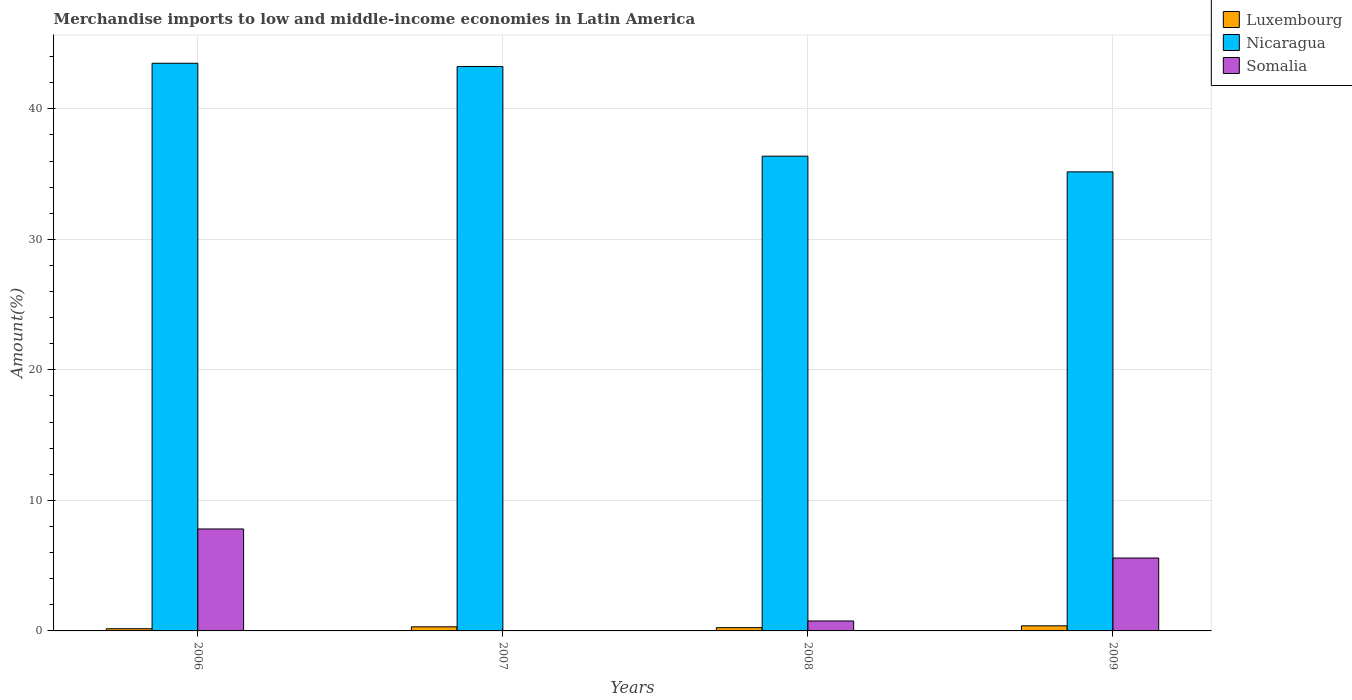How many different coloured bars are there?
Your answer should be compact. 3. How many groups of bars are there?
Provide a succinct answer. 4. Are the number of bars per tick equal to the number of legend labels?
Your answer should be very brief. Yes. Are the number of bars on each tick of the X-axis equal?
Ensure brevity in your answer.  Yes. How many bars are there on the 2nd tick from the right?
Provide a succinct answer. 3. What is the label of the 2nd group of bars from the left?
Give a very brief answer. 2007. In how many cases, is the number of bars for a given year not equal to the number of legend labels?
Keep it short and to the point. 0. What is the percentage of amount earned from merchandise imports in Somalia in 2009?
Provide a succinct answer. 5.59. Across all years, what is the maximum percentage of amount earned from merchandise imports in Luxembourg?
Your answer should be very brief. 0.39. Across all years, what is the minimum percentage of amount earned from merchandise imports in Somalia?
Offer a terse response. 0.02. In which year was the percentage of amount earned from merchandise imports in Somalia maximum?
Your response must be concise. 2006. In which year was the percentage of amount earned from merchandise imports in Somalia minimum?
Provide a short and direct response. 2007. What is the total percentage of amount earned from merchandise imports in Nicaragua in the graph?
Offer a very short reply. 158.27. What is the difference between the percentage of amount earned from merchandise imports in Somalia in 2007 and that in 2008?
Your answer should be compact. -0.74. What is the difference between the percentage of amount earned from merchandise imports in Luxembourg in 2008 and the percentage of amount earned from merchandise imports in Nicaragua in 2009?
Give a very brief answer. -34.92. What is the average percentage of amount earned from merchandise imports in Nicaragua per year?
Ensure brevity in your answer.  39.57. In the year 2006, what is the difference between the percentage of amount earned from merchandise imports in Somalia and percentage of amount earned from merchandise imports in Nicaragua?
Your response must be concise. -35.68. In how many years, is the percentage of amount earned from merchandise imports in Nicaragua greater than 10 %?
Keep it short and to the point. 4. What is the ratio of the percentage of amount earned from merchandise imports in Luxembourg in 2006 to that in 2009?
Your response must be concise. 0.43. Is the difference between the percentage of amount earned from merchandise imports in Somalia in 2006 and 2009 greater than the difference between the percentage of amount earned from merchandise imports in Nicaragua in 2006 and 2009?
Your answer should be compact. No. What is the difference between the highest and the second highest percentage of amount earned from merchandise imports in Somalia?
Your answer should be very brief. 2.23. What is the difference between the highest and the lowest percentage of amount earned from merchandise imports in Nicaragua?
Offer a terse response. 8.32. In how many years, is the percentage of amount earned from merchandise imports in Luxembourg greater than the average percentage of amount earned from merchandise imports in Luxembourg taken over all years?
Offer a very short reply. 2. What does the 3rd bar from the left in 2008 represents?
Your response must be concise. Somalia. What does the 3rd bar from the right in 2009 represents?
Keep it short and to the point. Luxembourg. Are the values on the major ticks of Y-axis written in scientific E-notation?
Offer a terse response. No. Does the graph contain grids?
Make the answer very short. Yes. What is the title of the graph?
Your answer should be very brief. Merchandise imports to low and middle-income economies in Latin America. Does "Liberia" appear as one of the legend labels in the graph?
Provide a succinct answer. No. What is the label or title of the Y-axis?
Your answer should be very brief. Amount(%). What is the Amount(%) in Luxembourg in 2006?
Give a very brief answer. 0.17. What is the Amount(%) of Nicaragua in 2006?
Your answer should be compact. 43.49. What is the Amount(%) in Somalia in 2006?
Make the answer very short. 7.81. What is the Amount(%) of Luxembourg in 2007?
Your response must be concise. 0.31. What is the Amount(%) in Nicaragua in 2007?
Provide a succinct answer. 43.24. What is the Amount(%) in Somalia in 2007?
Keep it short and to the point. 0.02. What is the Amount(%) in Luxembourg in 2008?
Your answer should be very brief. 0.25. What is the Amount(%) in Nicaragua in 2008?
Offer a very short reply. 36.37. What is the Amount(%) in Somalia in 2008?
Your answer should be compact. 0.76. What is the Amount(%) in Luxembourg in 2009?
Give a very brief answer. 0.39. What is the Amount(%) of Nicaragua in 2009?
Ensure brevity in your answer.  35.17. What is the Amount(%) in Somalia in 2009?
Your answer should be very brief. 5.59. Across all years, what is the maximum Amount(%) in Luxembourg?
Ensure brevity in your answer.  0.39. Across all years, what is the maximum Amount(%) of Nicaragua?
Your answer should be compact. 43.49. Across all years, what is the maximum Amount(%) of Somalia?
Keep it short and to the point. 7.81. Across all years, what is the minimum Amount(%) in Luxembourg?
Make the answer very short. 0.17. Across all years, what is the minimum Amount(%) of Nicaragua?
Keep it short and to the point. 35.17. Across all years, what is the minimum Amount(%) in Somalia?
Provide a succinct answer. 0.02. What is the total Amount(%) in Luxembourg in the graph?
Ensure brevity in your answer.  1.12. What is the total Amount(%) in Nicaragua in the graph?
Offer a very short reply. 158.27. What is the total Amount(%) of Somalia in the graph?
Keep it short and to the point. 14.18. What is the difference between the Amount(%) in Luxembourg in 2006 and that in 2007?
Ensure brevity in your answer.  -0.14. What is the difference between the Amount(%) of Nicaragua in 2006 and that in 2007?
Provide a succinct answer. 0.25. What is the difference between the Amount(%) of Somalia in 2006 and that in 2007?
Offer a very short reply. 7.79. What is the difference between the Amount(%) in Luxembourg in 2006 and that in 2008?
Ensure brevity in your answer.  -0.08. What is the difference between the Amount(%) in Nicaragua in 2006 and that in 2008?
Offer a very short reply. 7.12. What is the difference between the Amount(%) in Somalia in 2006 and that in 2008?
Your answer should be very brief. 7.05. What is the difference between the Amount(%) in Luxembourg in 2006 and that in 2009?
Your response must be concise. -0.22. What is the difference between the Amount(%) of Nicaragua in 2006 and that in 2009?
Offer a very short reply. 8.32. What is the difference between the Amount(%) of Somalia in 2006 and that in 2009?
Make the answer very short. 2.23. What is the difference between the Amount(%) in Luxembourg in 2007 and that in 2008?
Offer a terse response. 0.06. What is the difference between the Amount(%) of Nicaragua in 2007 and that in 2008?
Your answer should be compact. 6.87. What is the difference between the Amount(%) in Somalia in 2007 and that in 2008?
Your response must be concise. -0.74. What is the difference between the Amount(%) in Luxembourg in 2007 and that in 2009?
Your answer should be very brief. -0.08. What is the difference between the Amount(%) in Nicaragua in 2007 and that in 2009?
Ensure brevity in your answer.  8.07. What is the difference between the Amount(%) in Somalia in 2007 and that in 2009?
Give a very brief answer. -5.56. What is the difference between the Amount(%) in Luxembourg in 2008 and that in 2009?
Ensure brevity in your answer.  -0.14. What is the difference between the Amount(%) in Nicaragua in 2008 and that in 2009?
Your response must be concise. 1.2. What is the difference between the Amount(%) of Somalia in 2008 and that in 2009?
Your answer should be very brief. -4.82. What is the difference between the Amount(%) in Luxembourg in 2006 and the Amount(%) in Nicaragua in 2007?
Give a very brief answer. -43.07. What is the difference between the Amount(%) of Luxembourg in 2006 and the Amount(%) of Somalia in 2007?
Offer a terse response. 0.15. What is the difference between the Amount(%) in Nicaragua in 2006 and the Amount(%) in Somalia in 2007?
Ensure brevity in your answer.  43.47. What is the difference between the Amount(%) of Luxembourg in 2006 and the Amount(%) of Nicaragua in 2008?
Offer a very short reply. -36.2. What is the difference between the Amount(%) in Luxembourg in 2006 and the Amount(%) in Somalia in 2008?
Keep it short and to the point. -0.59. What is the difference between the Amount(%) of Nicaragua in 2006 and the Amount(%) of Somalia in 2008?
Your answer should be very brief. 42.73. What is the difference between the Amount(%) in Luxembourg in 2006 and the Amount(%) in Nicaragua in 2009?
Your answer should be very brief. -35. What is the difference between the Amount(%) of Luxembourg in 2006 and the Amount(%) of Somalia in 2009?
Offer a terse response. -5.42. What is the difference between the Amount(%) of Nicaragua in 2006 and the Amount(%) of Somalia in 2009?
Your answer should be very brief. 37.9. What is the difference between the Amount(%) of Luxembourg in 2007 and the Amount(%) of Nicaragua in 2008?
Your answer should be compact. -36.06. What is the difference between the Amount(%) in Luxembourg in 2007 and the Amount(%) in Somalia in 2008?
Offer a very short reply. -0.45. What is the difference between the Amount(%) in Nicaragua in 2007 and the Amount(%) in Somalia in 2008?
Offer a very short reply. 42.48. What is the difference between the Amount(%) of Luxembourg in 2007 and the Amount(%) of Nicaragua in 2009?
Give a very brief answer. -34.86. What is the difference between the Amount(%) in Luxembourg in 2007 and the Amount(%) in Somalia in 2009?
Your response must be concise. -5.27. What is the difference between the Amount(%) of Nicaragua in 2007 and the Amount(%) of Somalia in 2009?
Make the answer very short. 37.65. What is the difference between the Amount(%) of Luxembourg in 2008 and the Amount(%) of Nicaragua in 2009?
Offer a very short reply. -34.92. What is the difference between the Amount(%) in Luxembourg in 2008 and the Amount(%) in Somalia in 2009?
Offer a terse response. -5.34. What is the difference between the Amount(%) of Nicaragua in 2008 and the Amount(%) of Somalia in 2009?
Provide a short and direct response. 30.79. What is the average Amount(%) of Luxembourg per year?
Ensure brevity in your answer.  0.28. What is the average Amount(%) of Nicaragua per year?
Make the answer very short. 39.57. What is the average Amount(%) in Somalia per year?
Your response must be concise. 3.54. In the year 2006, what is the difference between the Amount(%) in Luxembourg and Amount(%) in Nicaragua?
Ensure brevity in your answer.  -43.32. In the year 2006, what is the difference between the Amount(%) of Luxembourg and Amount(%) of Somalia?
Your response must be concise. -7.64. In the year 2006, what is the difference between the Amount(%) of Nicaragua and Amount(%) of Somalia?
Your response must be concise. 35.68. In the year 2007, what is the difference between the Amount(%) of Luxembourg and Amount(%) of Nicaragua?
Keep it short and to the point. -42.93. In the year 2007, what is the difference between the Amount(%) in Luxembourg and Amount(%) in Somalia?
Ensure brevity in your answer.  0.29. In the year 2007, what is the difference between the Amount(%) of Nicaragua and Amount(%) of Somalia?
Offer a terse response. 43.22. In the year 2008, what is the difference between the Amount(%) of Luxembourg and Amount(%) of Nicaragua?
Make the answer very short. -36.12. In the year 2008, what is the difference between the Amount(%) of Luxembourg and Amount(%) of Somalia?
Your response must be concise. -0.51. In the year 2008, what is the difference between the Amount(%) in Nicaragua and Amount(%) in Somalia?
Offer a very short reply. 35.61. In the year 2009, what is the difference between the Amount(%) of Luxembourg and Amount(%) of Nicaragua?
Give a very brief answer. -34.78. In the year 2009, what is the difference between the Amount(%) in Luxembourg and Amount(%) in Somalia?
Ensure brevity in your answer.  -5.19. In the year 2009, what is the difference between the Amount(%) in Nicaragua and Amount(%) in Somalia?
Offer a very short reply. 29.58. What is the ratio of the Amount(%) in Luxembourg in 2006 to that in 2007?
Your response must be concise. 0.54. What is the ratio of the Amount(%) of Somalia in 2006 to that in 2007?
Your answer should be very brief. 379.63. What is the ratio of the Amount(%) of Luxembourg in 2006 to that in 2008?
Give a very brief answer. 0.68. What is the ratio of the Amount(%) of Nicaragua in 2006 to that in 2008?
Provide a short and direct response. 1.2. What is the ratio of the Amount(%) in Somalia in 2006 to that in 2008?
Offer a terse response. 10.24. What is the ratio of the Amount(%) in Luxembourg in 2006 to that in 2009?
Provide a succinct answer. 0.43. What is the ratio of the Amount(%) of Nicaragua in 2006 to that in 2009?
Ensure brevity in your answer.  1.24. What is the ratio of the Amount(%) in Somalia in 2006 to that in 2009?
Offer a very short reply. 1.4. What is the ratio of the Amount(%) of Luxembourg in 2007 to that in 2008?
Provide a short and direct response. 1.26. What is the ratio of the Amount(%) in Nicaragua in 2007 to that in 2008?
Make the answer very short. 1.19. What is the ratio of the Amount(%) in Somalia in 2007 to that in 2008?
Offer a terse response. 0.03. What is the ratio of the Amount(%) of Luxembourg in 2007 to that in 2009?
Keep it short and to the point. 0.8. What is the ratio of the Amount(%) in Nicaragua in 2007 to that in 2009?
Your answer should be compact. 1.23. What is the ratio of the Amount(%) in Somalia in 2007 to that in 2009?
Offer a terse response. 0. What is the ratio of the Amount(%) in Luxembourg in 2008 to that in 2009?
Provide a short and direct response. 0.64. What is the ratio of the Amount(%) in Nicaragua in 2008 to that in 2009?
Your response must be concise. 1.03. What is the ratio of the Amount(%) of Somalia in 2008 to that in 2009?
Your answer should be very brief. 0.14. What is the difference between the highest and the second highest Amount(%) in Luxembourg?
Provide a succinct answer. 0.08. What is the difference between the highest and the second highest Amount(%) of Nicaragua?
Offer a terse response. 0.25. What is the difference between the highest and the second highest Amount(%) in Somalia?
Your answer should be compact. 2.23. What is the difference between the highest and the lowest Amount(%) in Luxembourg?
Your answer should be very brief. 0.22. What is the difference between the highest and the lowest Amount(%) in Nicaragua?
Your answer should be compact. 8.32. What is the difference between the highest and the lowest Amount(%) of Somalia?
Provide a short and direct response. 7.79. 